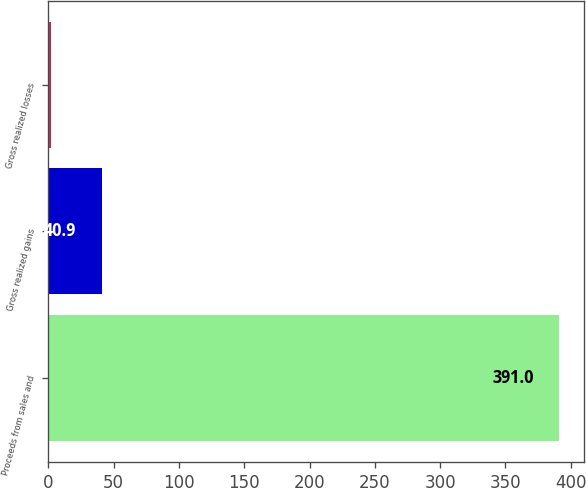<chart> <loc_0><loc_0><loc_500><loc_500><bar_chart><fcel>Proceeds from sales and<fcel>Gross realized gains<fcel>Gross realized losses<nl><fcel>391<fcel>40.9<fcel>2<nl></chart> 